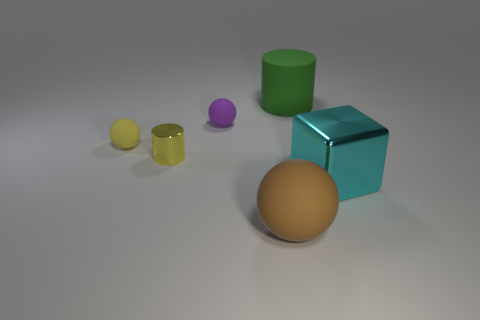Is the yellow matte object the same size as the brown rubber ball?
Make the answer very short. No. The small object that is made of the same material as the yellow sphere is what shape?
Ensure brevity in your answer.  Sphere. How many other objects are there of the same shape as the large cyan metallic object?
Your response must be concise. 0. There is a metallic object that is to the left of the small rubber object right of the rubber ball left of the tiny metallic cylinder; what is its shape?
Your answer should be compact. Cylinder. How many cylinders are either big green matte objects or small yellow matte things?
Your response must be concise. 1. Are there any spheres that are behind the shiny object that is behind the large cyan object?
Your response must be concise. Yes. Is there anything else that has the same material as the small yellow cylinder?
Keep it short and to the point. Yes. There is a purple rubber object; is its shape the same as the big thing that is behind the cyan metallic block?
Your response must be concise. No. How many other objects are there of the same size as the yellow rubber thing?
Your answer should be very brief. 2. How many blue objects are either small rubber spheres or shiny things?
Your response must be concise. 0. 